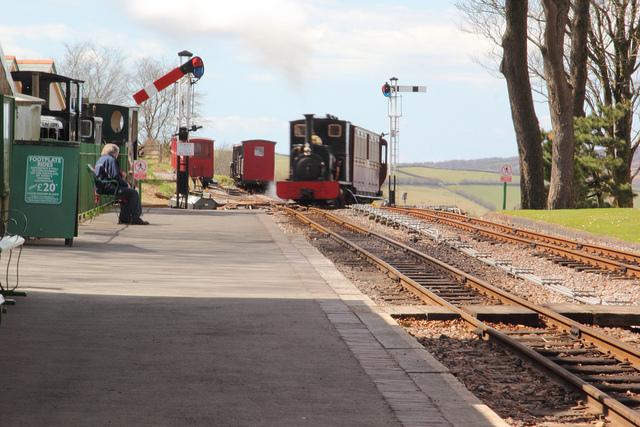What is the sidewalk made of?
Concise answer only. Concrete. How many people are on the platform?
Quick response, please. 1. What sort of zoning is in the background?
Quick response, please. Train. Are the tracks rusty?
Keep it brief. Yes. Is there more then 2 people here?
Give a very brief answer. No. How many tracks run here?
Be succinct. 2. What time of day might this be?
Answer briefly. Afternoon. 